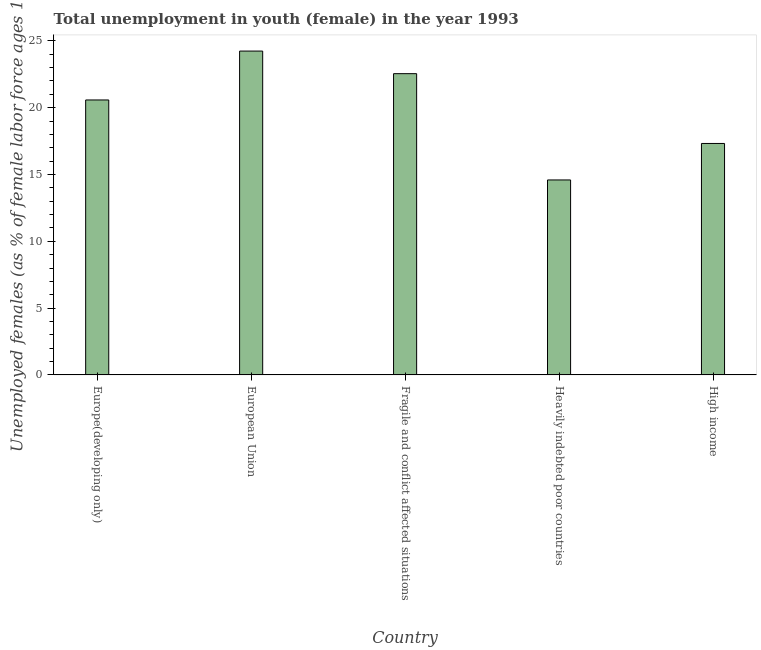Does the graph contain grids?
Offer a very short reply. No. What is the title of the graph?
Offer a very short reply. Total unemployment in youth (female) in the year 1993. What is the label or title of the Y-axis?
Offer a terse response. Unemployed females (as % of female labor force ages 15-24). What is the unemployed female youth population in Heavily indebted poor countries?
Provide a short and direct response. 14.59. Across all countries, what is the maximum unemployed female youth population?
Your answer should be compact. 24.24. Across all countries, what is the minimum unemployed female youth population?
Ensure brevity in your answer.  14.59. In which country was the unemployed female youth population minimum?
Ensure brevity in your answer.  Heavily indebted poor countries. What is the sum of the unemployed female youth population?
Ensure brevity in your answer.  99.29. What is the difference between the unemployed female youth population in European Union and High income?
Offer a very short reply. 6.92. What is the average unemployed female youth population per country?
Ensure brevity in your answer.  19.86. What is the median unemployed female youth population?
Provide a short and direct response. 20.58. In how many countries, is the unemployed female youth population greater than 24 %?
Offer a terse response. 1. What is the ratio of the unemployed female youth population in European Union to that in Heavily indebted poor countries?
Make the answer very short. 1.66. What is the difference between the highest and the second highest unemployed female youth population?
Provide a short and direct response. 1.69. Is the sum of the unemployed female youth population in Fragile and conflict affected situations and High income greater than the maximum unemployed female youth population across all countries?
Provide a short and direct response. Yes. What is the difference between the highest and the lowest unemployed female youth population?
Offer a terse response. 9.65. In how many countries, is the unemployed female youth population greater than the average unemployed female youth population taken over all countries?
Ensure brevity in your answer.  3. How many bars are there?
Make the answer very short. 5. Are all the bars in the graph horizontal?
Ensure brevity in your answer.  No. What is the Unemployed females (as % of female labor force ages 15-24) of Europe(developing only)?
Your answer should be compact. 20.58. What is the Unemployed females (as % of female labor force ages 15-24) in European Union?
Ensure brevity in your answer.  24.24. What is the Unemployed females (as % of female labor force ages 15-24) of Fragile and conflict affected situations?
Provide a succinct answer. 22.55. What is the Unemployed females (as % of female labor force ages 15-24) in Heavily indebted poor countries?
Give a very brief answer. 14.59. What is the Unemployed females (as % of female labor force ages 15-24) of High income?
Ensure brevity in your answer.  17.32. What is the difference between the Unemployed females (as % of female labor force ages 15-24) in Europe(developing only) and European Union?
Offer a very short reply. -3.66. What is the difference between the Unemployed females (as % of female labor force ages 15-24) in Europe(developing only) and Fragile and conflict affected situations?
Your answer should be very brief. -1.97. What is the difference between the Unemployed females (as % of female labor force ages 15-24) in Europe(developing only) and Heavily indebted poor countries?
Keep it short and to the point. 5.99. What is the difference between the Unemployed females (as % of female labor force ages 15-24) in Europe(developing only) and High income?
Make the answer very short. 3.26. What is the difference between the Unemployed females (as % of female labor force ages 15-24) in European Union and Fragile and conflict affected situations?
Provide a succinct answer. 1.69. What is the difference between the Unemployed females (as % of female labor force ages 15-24) in European Union and Heavily indebted poor countries?
Keep it short and to the point. 9.65. What is the difference between the Unemployed females (as % of female labor force ages 15-24) in European Union and High income?
Provide a short and direct response. 6.92. What is the difference between the Unemployed females (as % of female labor force ages 15-24) in Fragile and conflict affected situations and Heavily indebted poor countries?
Your response must be concise. 7.96. What is the difference between the Unemployed females (as % of female labor force ages 15-24) in Fragile and conflict affected situations and High income?
Offer a terse response. 5.22. What is the difference between the Unemployed females (as % of female labor force ages 15-24) in Heavily indebted poor countries and High income?
Keep it short and to the point. -2.73. What is the ratio of the Unemployed females (as % of female labor force ages 15-24) in Europe(developing only) to that in European Union?
Provide a succinct answer. 0.85. What is the ratio of the Unemployed females (as % of female labor force ages 15-24) in Europe(developing only) to that in Fragile and conflict affected situations?
Make the answer very short. 0.91. What is the ratio of the Unemployed females (as % of female labor force ages 15-24) in Europe(developing only) to that in Heavily indebted poor countries?
Provide a succinct answer. 1.41. What is the ratio of the Unemployed females (as % of female labor force ages 15-24) in Europe(developing only) to that in High income?
Offer a terse response. 1.19. What is the ratio of the Unemployed females (as % of female labor force ages 15-24) in European Union to that in Fragile and conflict affected situations?
Offer a very short reply. 1.07. What is the ratio of the Unemployed females (as % of female labor force ages 15-24) in European Union to that in Heavily indebted poor countries?
Offer a very short reply. 1.66. What is the ratio of the Unemployed females (as % of female labor force ages 15-24) in European Union to that in High income?
Provide a succinct answer. 1.4. What is the ratio of the Unemployed females (as % of female labor force ages 15-24) in Fragile and conflict affected situations to that in Heavily indebted poor countries?
Provide a succinct answer. 1.54. What is the ratio of the Unemployed females (as % of female labor force ages 15-24) in Fragile and conflict affected situations to that in High income?
Keep it short and to the point. 1.3. What is the ratio of the Unemployed females (as % of female labor force ages 15-24) in Heavily indebted poor countries to that in High income?
Give a very brief answer. 0.84. 